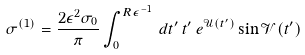<formula> <loc_0><loc_0><loc_500><loc_500>\sigma ^ { ( 1 ) } = \frac { 2 \epsilon ^ { 2 } \sigma _ { 0 } } { \pi } \int _ { 0 } ^ { R \epsilon ^ { - 1 } } \, d t ^ { \prime } \, t ^ { \prime } \, e ^ { \mathcal { U } ( t ^ { \prime } ) } \sin { \mathcal { V } ( t ^ { \prime } ) }</formula> 